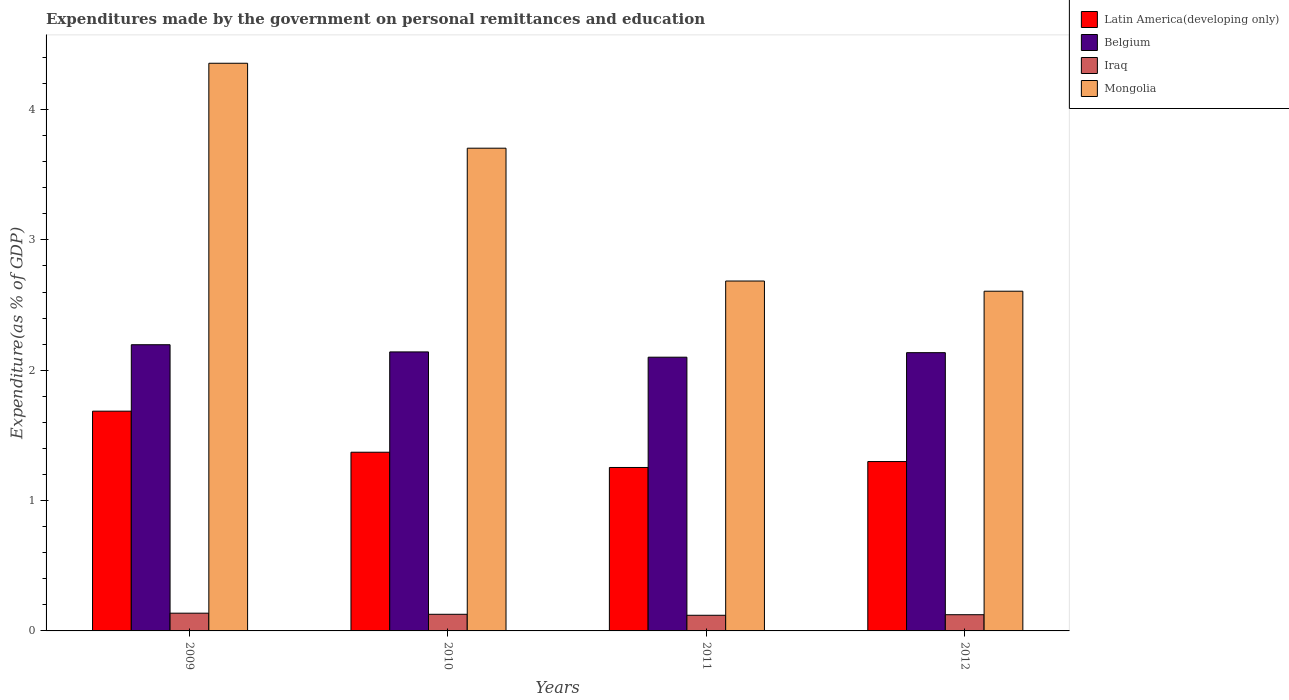How many different coloured bars are there?
Your response must be concise. 4. How many groups of bars are there?
Provide a short and direct response. 4. Are the number of bars per tick equal to the number of legend labels?
Your answer should be very brief. Yes. Are the number of bars on each tick of the X-axis equal?
Offer a very short reply. Yes. How many bars are there on the 4th tick from the right?
Offer a terse response. 4. What is the label of the 1st group of bars from the left?
Provide a succinct answer. 2009. In how many cases, is the number of bars for a given year not equal to the number of legend labels?
Your answer should be compact. 0. What is the expenditures made by the government on personal remittances and education in Belgium in 2009?
Your answer should be compact. 2.2. Across all years, what is the maximum expenditures made by the government on personal remittances and education in Mongolia?
Offer a very short reply. 4.35. Across all years, what is the minimum expenditures made by the government on personal remittances and education in Mongolia?
Make the answer very short. 2.61. What is the total expenditures made by the government on personal remittances and education in Iraq in the graph?
Make the answer very short. 0.51. What is the difference between the expenditures made by the government on personal remittances and education in Belgium in 2009 and that in 2011?
Your answer should be very brief. 0.1. What is the difference between the expenditures made by the government on personal remittances and education in Iraq in 2011 and the expenditures made by the government on personal remittances and education in Latin America(developing only) in 2009?
Your answer should be very brief. -1.57. What is the average expenditures made by the government on personal remittances and education in Mongolia per year?
Keep it short and to the point. 3.34. In the year 2011, what is the difference between the expenditures made by the government on personal remittances and education in Latin America(developing only) and expenditures made by the government on personal remittances and education in Iraq?
Your answer should be compact. 1.13. What is the ratio of the expenditures made by the government on personal remittances and education in Latin America(developing only) in 2009 to that in 2010?
Provide a short and direct response. 1.23. Is the expenditures made by the government on personal remittances and education in Latin America(developing only) in 2010 less than that in 2011?
Provide a short and direct response. No. What is the difference between the highest and the second highest expenditures made by the government on personal remittances and education in Mongolia?
Offer a very short reply. 0.65. What is the difference between the highest and the lowest expenditures made by the government on personal remittances and education in Belgium?
Provide a succinct answer. 0.1. In how many years, is the expenditures made by the government on personal remittances and education in Iraq greater than the average expenditures made by the government on personal remittances and education in Iraq taken over all years?
Your response must be concise. 2. What does the 3rd bar from the left in 2009 represents?
Ensure brevity in your answer.  Iraq. What does the 2nd bar from the right in 2009 represents?
Give a very brief answer. Iraq. How many bars are there?
Provide a short and direct response. 16. What is the difference between two consecutive major ticks on the Y-axis?
Your answer should be very brief. 1. How many legend labels are there?
Ensure brevity in your answer.  4. How are the legend labels stacked?
Keep it short and to the point. Vertical. What is the title of the graph?
Make the answer very short. Expenditures made by the government on personal remittances and education. Does "Denmark" appear as one of the legend labels in the graph?
Your answer should be compact. No. What is the label or title of the Y-axis?
Ensure brevity in your answer.  Expenditure(as % of GDP). What is the Expenditure(as % of GDP) of Latin America(developing only) in 2009?
Your answer should be compact. 1.69. What is the Expenditure(as % of GDP) in Belgium in 2009?
Your response must be concise. 2.2. What is the Expenditure(as % of GDP) of Iraq in 2009?
Offer a very short reply. 0.14. What is the Expenditure(as % of GDP) of Mongolia in 2009?
Offer a very short reply. 4.35. What is the Expenditure(as % of GDP) in Latin America(developing only) in 2010?
Keep it short and to the point. 1.37. What is the Expenditure(as % of GDP) in Belgium in 2010?
Offer a very short reply. 2.14. What is the Expenditure(as % of GDP) of Iraq in 2010?
Offer a terse response. 0.13. What is the Expenditure(as % of GDP) of Mongolia in 2010?
Offer a very short reply. 3.7. What is the Expenditure(as % of GDP) of Latin America(developing only) in 2011?
Provide a short and direct response. 1.25. What is the Expenditure(as % of GDP) in Belgium in 2011?
Keep it short and to the point. 2.1. What is the Expenditure(as % of GDP) in Iraq in 2011?
Ensure brevity in your answer.  0.12. What is the Expenditure(as % of GDP) in Mongolia in 2011?
Provide a short and direct response. 2.68. What is the Expenditure(as % of GDP) in Latin America(developing only) in 2012?
Keep it short and to the point. 1.3. What is the Expenditure(as % of GDP) of Belgium in 2012?
Offer a terse response. 2.13. What is the Expenditure(as % of GDP) in Iraq in 2012?
Ensure brevity in your answer.  0.12. What is the Expenditure(as % of GDP) of Mongolia in 2012?
Offer a terse response. 2.61. Across all years, what is the maximum Expenditure(as % of GDP) in Latin America(developing only)?
Offer a very short reply. 1.69. Across all years, what is the maximum Expenditure(as % of GDP) of Belgium?
Offer a terse response. 2.2. Across all years, what is the maximum Expenditure(as % of GDP) of Iraq?
Your response must be concise. 0.14. Across all years, what is the maximum Expenditure(as % of GDP) of Mongolia?
Offer a terse response. 4.35. Across all years, what is the minimum Expenditure(as % of GDP) in Latin America(developing only)?
Provide a short and direct response. 1.25. Across all years, what is the minimum Expenditure(as % of GDP) in Belgium?
Provide a short and direct response. 2.1. Across all years, what is the minimum Expenditure(as % of GDP) of Iraq?
Give a very brief answer. 0.12. Across all years, what is the minimum Expenditure(as % of GDP) of Mongolia?
Make the answer very short. 2.61. What is the total Expenditure(as % of GDP) in Latin America(developing only) in the graph?
Give a very brief answer. 5.61. What is the total Expenditure(as % of GDP) of Belgium in the graph?
Give a very brief answer. 8.57. What is the total Expenditure(as % of GDP) of Iraq in the graph?
Provide a succinct answer. 0.51. What is the total Expenditure(as % of GDP) of Mongolia in the graph?
Keep it short and to the point. 13.35. What is the difference between the Expenditure(as % of GDP) in Latin America(developing only) in 2009 and that in 2010?
Provide a short and direct response. 0.32. What is the difference between the Expenditure(as % of GDP) in Belgium in 2009 and that in 2010?
Ensure brevity in your answer.  0.06. What is the difference between the Expenditure(as % of GDP) in Iraq in 2009 and that in 2010?
Offer a terse response. 0.01. What is the difference between the Expenditure(as % of GDP) of Mongolia in 2009 and that in 2010?
Make the answer very short. 0.65. What is the difference between the Expenditure(as % of GDP) of Latin America(developing only) in 2009 and that in 2011?
Offer a very short reply. 0.43. What is the difference between the Expenditure(as % of GDP) in Belgium in 2009 and that in 2011?
Your answer should be compact. 0.1. What is the difference between the Expenditure(as % of GDP) of Iraq in 2009 and that in 2011?
Offer a very short reply. 0.02. What is the difference between the Expenditure(as % of GDP) in Mongolia in 2009 and that in 2011?
Offer a terse response. 1.67. What is the difference between the Expenditure(as % of GDP) of Latin America(developing only) in 2009 and that in 2012?
Offer a very short reply. 0.39. What is the difference between the Expenditure(as % of GDP) in Belgium in 2009 and that in 2012?
Offer a very short reply. 0.06. What is the difference between the Expenditure(as % of GDP) of Iraq in 2009 and that in 2012?
Offer a terse response. 0.01. What is the difference between the Expenditure(as % of GDP) of Mongolia in 2009 and that in 2012?
Keep it short and to the point. 1.75. What is the difference between the Expenditure(as % of GDP) of Latin America(developing only) in 2010 and that in 2011?
Offer a very short reply. 0.12. What is the difference between the Expenditure(as % of GDP) of Belgium in 2010 and that in 2011?
Offer a very short reply. 0.04. What is the difference between the Expenditure(as % of GDP) of Iraq in 2010 and that in 2011?
Ensure brevity in your answer.  0.01. What is the difference between the Expenditure(as % of GDP) in Latin America(developing only) in 2010 and that in 2012?
Your answer should be very brief. 0.07. What is the difference between the Expenditure(as % of GDP) in Belgium in 2010 and that in 2012?
Make the answer very short. 0.01. What is the difference between the Expenditure(as % of GDP) in Iraq in 2010 and that in 2012?
Give a very brief answer. 0. What is the difference between the Expenditure(as % of GDP) of Mongolia in 2010 and that in 2012?
Make the answer very short. 1.1. What is the difference between the Expenditure(as % of GDP) of Latin America(developing only) in 2011 and that in 2012?
Make the answer very short. -0.05. What is the difference between the Expenditure(as % of GDP) in Belgium in 2011 and that in 2012?
Keep it short and to the point. -0.03. What is the difference between the Expenditure(as % of GDP) of Iraq in 2011 and that in 2012?
Offer a very short reply. -0. What is the difference between the Expenditure(as % of GDP) in Mongolia in 2011 and that in 2012?
Offer a terse response. 0.08. What is the difference between the Expenditure(as % of GDP) of Latin America(developing only) in 2009 and the Expenditure(as % of GDP) of Belgium in 2010?
Provide a succinct answer. -0.45. What is the difference between the Expenditure(as % of GDP) of Latin America(developing only) in 2009 and the Expenditure(as % of GDP) of Iraq in 2010?
Keep it short and to the point. 1.56. What is the difference between the Expenditure(as % of GDP) of Latin America(developing only) in 2009 and the Expenditure(as % of GDP) of Mongolia in 2010?
Your response must be concise. -2.02. What is the difference between the Expenditure(as % of GDP) of Belgium in 2009 and the Expenditure(as % of GDP) of Iraq in 2010?
Make the answer very short. 2.07. What is the difference between the Expenditure(as % of GDP) of Belgium in 2009 and the Expenditure(as % of GDP) of Mongolia in 2010?
Make the answer very short. -1.51. What is the difference between the Expenditure(as % of GDP) of Iraq in 2009 and the Expenditure(as % of GDP) of Mongolia in 2010?
Make the answer very short. -3.57. What is the difference between the Expenditure(as % of GDP) of Latin America(developing only) in 2009 and the Expenditure(as % of GDP) of Belgium in 2011?
Provide a short and direct response. -0.41. What is the difference between the Expenditure(as % of GDP) in Latin America(developing only) in 2009 and the Expenditure(as % of GDP) in Iraq in 2011?
Keep it short and to the point. 1.57. What is the difference between the Expenditure(as % of GDP) in Latin America(developing only) in 2009 and the Expenditure(as % of GDP) in Mongolia in 2011?
Offer a very short reply. -1. What is the difference between the Expenditure(as % of GDP) in Belgium in 2009 and the Expenditure(as % of GDP) in Iraq in 2011?
Keep it short and to the point. 2.08. What is the difference between the Expenditure(as % of GDP) of Belgium in 2009 and the Expenditure(as % of GDP) of Mongolia in 2011?
Provide a short and direct response. -0.49. What is the difference between the Expenditure(as % of GDP) of Iraq in 2009 and the Expenditure(as % of GDP) of Mongolia in 2011?
Make the answer very short. -2.55. What is the difference between the Expenditure(as % of GDP) of Latin America(developing only) in 2009 and the Expenditure(as % of GDP) of Belgium in 2012?
Make the answer very short. -0.45. What is the difference between the Expenditure(as % of GDP) in Latin America(developing only) in 2009 and the Expenditure(as % of GDP) in Iraq in 2012?
Provide a short and direct response. 1.56. What is the difference between the Expenditure(as % of GDP) in Latin America(developing only) in 2009 and the Expenditure(as % of GDP) in Mongolia in 2012?
Provide a short and direct response. -0.92. What is the difference between the Expenditure(as % of GDP) of Belgium in 2009 and the Expenditure(as % of GDP) of Iraq in 2012?
Make the answer very short. 2.07. What is the difference between the Expenditure(as % of GDP) of Belgium in 2009 and the Expenditure(as % of GDP) of Mongolia in 2012?
Provide a short and direct response. -0.41. What is the difference between the Expenditure(as % of GDP) in Iraq in 2009 and the Expenditure(as % of GDP) in Mongolia in 2012?
Provide a short and direct response. -2.47. What is the difference between the Expenditure(as % of GDP) of Latin America(developing only) in 2010 and the Expenditure(as % of GDP) of Belgium in 2011?
Ensure brevity in your answer.  -0.73. What is the difference between the Expenditure(as % of GDP) of Latin America(developing only) in 2010 and the Expenditure(as % of GDP) of Iraq in 2011?
Your answer should be compact. 1.25. What is the difference between the Expenditure(as % of GDP) in Latin America(developing only) in 2010 and the Expenditure(as % of GDP) in Mongolia in 2011?
Keep it short and to the point. -1.31. What is the difference between the Expenditure(as % of GDP) in Belgium in 2010 and the Expenditure(as % of GDP) in Iraq in 2011?
Give a very brief answer. 2.02. What is the difference between the Expenditure(as % of GDP) of Belgium in 2010 and the Expenditure(as % of GDP) of Mongolia in 2011?
Offer a very short reply. -0.54. What is the difference between the Expenditure(as % of GDP) in Iraq in 2010 and the Expenditure(as % of GDP) in Mongolia in 2011?
Provide a succinct answer. -2.56. What is the difference between the Expenditure(as % of GDP) in Latin America(developing only) in 2010 and the Expenditure(as % of GDP) in Belgium in 2012?
Provide a short and direct response. -0.76. What is the difference between the Expenditure(as % of GDP) of Latin America(developing only) in 2010 and the Expenditure(as % of GDP) of Iraq in 2012?
Make the answer very short. 1.25. What is the difference between the Expenditure(as % of GDP) of Latin America(developing only) in 2010 and the Expenditure(as % of GDP) of Mongolia in 2012?
Ensure brevity in your answer.  -1.24. What is the difference between the Expenditure(as % of GDP) of Belgium in 2010 and the Expenditure(as % of GDP) of Iraq in 2012?
Provide a succinct answer. 2.02. What is the difference between the Expenditure(as % of GDP) in Belgium in 2010 and the Expenditure(as % of GDP) in Mongolia in 2012?
Your answer should be very brief. -0.47. What is the difference between the Expenditure(as % of GDP) in Iraq in 2010 and the Expenditure(as % of GDP) in Mongolia in 2012?
Make the answer very short. -2.48. What is the difference between the Expenditure(as % of GDP) in Latin America(developing only) in 2011 and the Expenditure(as % of GDP) in Belgium in 2012?
Offer a terse response. -0.88. What is the difference between the Expenditure(as % of GDP) of Latin America(developing only) in 2011 and the Expenditure(as % of GDP) of Iraq in 2012?
Keep it short and to the point. 1.13. What is the difference between the Expenditure(as % of GDP) of Latin America(developing only) in 2011 and the Expenditure(as % of GDP) of Mongolia in 2012?
Give a very brief answer. -1.35. What is the difference between the Expenditure(as % of GDP) of Belgium in 2011 and the Expenditure(as % of GDP) of Iraq in 2012?
Keep it short and to the point. 1.98. What is the difference between the Expenditure(as % of GDP) in Belgium in 2011 and the Expenditure(as % of GDP) in Mongolia in 2012?
Provide a succinct answer. -0.51. What is the difference between the Expenditure(as % of GDP) in Iraq in 2011 and the Expenditure(as % of GDP) in Mongolia in 2012?
Offer a very short reply. -2.49. What is the average Expenditure(as % of GDP) of Latin America(developing only) per year?
Provide a succinct answer. 1.4. What is the average Expenditure(as % of GDP) in Belgium per year?
Ensure brevity in your answer.  2.14. What is the average Expenditure(as % of GDP) of Iraq per year?
Your answer should be very brief. 0.13. What is the average Expenditure(as % of GDP) in Mongolia per year?
Your answer should be very brief. 3.34. In the year 2009, what is the difference between the Expenditure(as % of GDP) of Latin America(developing only) and Expenditure(as % of GDP) of Belgium?
Provide a short and direct response. -0.51. In the year 2009, what is the difference between the Expenditure(as % of GDP) of Latin America(developing only) and Expenditure(as % of GDP) of Iraq?
Offer a terse response. 1.55. In the year 2009, what is the difference between the Expenditure(as % of GDP) in Latin America(developing only) and Expenditure(as % of GDP) in Mongolia?
Your response must be concise. -2.67. In the year 2009, what is the difference between the Expenditure(as % of GDP) in Belgium and Expenditure(as % of GDP) in Iraq?
Your answer should be very brief. 2.06. In the year 2009, what is the difference between the Expenditure(as % of GDP) of Belgium and Expenditure(as % of GDP) of Mongolia?
Your answer should be compact. -2.16. In the year 2009, what is the difference between the Expenditure(as % of GDP) in Iraq and Expenditure(as % of GDP) in Mongolia?
Your answer should be compact. -4.22. In the year 2010, what is the difference between the Expenditure(as % of GDP) of Latin America(developing only) and Expenditure(as % of GDP) of Belgium?
Your response must be concise. -0.77. In the year 2010, what is the difference between the Expenditure(as % of GDP) of Latin America(developing only) and Expenditure(as % of GDP) of Iraq?
Make the answer very short. 1.24. In the year 2010, what is the difference between the Expenditure(as % of GDP) of Latin America(developing only) and Expenditure(as % of GDP) of Mongolia?
Offer a terse response. -2.33. In the year 2010, what is the difference between the Expenditure(as % of GDP) in Belgium and Expenditure(as % of GDP) in Iraq?
Make the answer very short. 2.01. In the year 2010, what is the difference between the Expenditure(as % of GDP) in Belgium and Expenditure(as % of GDP) in Mongolia?
Provide a short and direct response. -1.56. In the year 2010, what is the difference between the Expenditure(as % of GDP) in Iraq and Expenditure(as % of GDP) in Mongolia?
Your answer should be compact. -3.58. In the year 2011, what is the difference between the Expenditure(as % of GDP) in Latin America(developing only) and Expenditure(as % of GDP) in Belgium?
Your response must be concise. -0.85. In the year 2011, what is the difference between the Expenditure(as % of GDP) of Latin America(developing only) and Expenditure(as % of GDP) of Iraq?
Your answer should be very brief. 1.13. In the year 2011, what is the difference between the Expenditure(as % of GDP) in Latin America(developing only) and Expenditure(as % of GDP) in Mongolia?
Offer a very short reply. -1.43. In the year 2011, what is the difference between the Expenditure(as % of GDP) in Belgium and Expenditure(as % of GDP) in Iraq?
Your answer should be compact. 1.98. In the year 2011, what is the difference between the Expenditure(as % of GDP) of Belgium and Expenditure(as % of GDP) of Mongolia?
Make the answer very short. -0.58. In the year 2011, what is the difference between the Expenditure(as % of GDP) of Iraq and Expenditure(as % of GDP) of Mongolia?
Provide a succinct answer. -2.56. In the year 2012, what is the difference between the Expenditure(as % of GDP) in Latin America(developing only) and Expenditure(as % of GDP) in Belgium?
Your answer should be very brief. -0.84. In the year 2012, what is the difference between the Expenditure(as % of GDP) of Latin America(developing only) and Expenditure(as % of GDP) of Iraq?
Make the answer very short. 1.18. In the year 2012, what is the difference between the Expenditure(as % of GDP) of Latin America(developing only) and Expenditure(as % of GDP) of Mongolia?
Ensure brevity in your answer.  -1.31. In the year 2012, what is the difference between the Expenditure(as % of GDP) of Belgium and Expenditure(as % of GDP) of Iraq?
Offer a terse response. 2.01. In the year 2012, what is the difference between the Expenditure(as % of GDP) in Belgium and Expenditure(as % of GDP) in Mongolia?
Give a very brief answer. -0.47. In the year 2012, what is the difference between the Expenditure(as % of GDP) of Iraq and Expenditure(as % of GDP) of Mongolia?
Offer a very short reply. -2.48. What is the ratio of the Expenditure(as % of GDP) of Latin America(developing only) in 2009 to that in 2010?
Provide a short and direct response. 1.23. What is the ratio of the Expenditure(as % of GDP) in Belgium in 2009 to that in 2010?
Your answer should be compact. 1.03. What is the ratio of the Expenditure(as % of GDP) of Iraq in 2009 to that in 2010?
Keep it short and to the point. 1.07. What is the ratio of the Expenditure(as % of GDP) in Mongolia in 2009 to that in 2010?
Offer a very short reply. 1.18. What is the ratio of the Expenditure(as % of GDP) of Latin America(developing only) in 2009 to that in 2011?
Your response must be concise. 1.34. What is the ratio of the Expenditure(as % of GDP) of Belgium in 2009 to that in 2011?
Your response must be concise. 1.05. What is the ratio of the Expenditure(as % of GDP) in Iraq in 2009 to that in 2011?
Offer a very short reply. 1.13. What is the ratio of the Expenditure(as % of GDP) of Mongolia in 2009 to that in 2011?
Provide a short and direct response. 1.62. What is the ratio of the Expenditure(as % of GDP) in Latin America(developing only) in 2009 to that in 2012?
Offer a terse response. 1.3. What is the ratio of the Expenditure(as % of GDP) of Belgium in 2009 to that in 2012?
Provide a succinct answer. 1.03. What is the ratio of the Expenditure(as % of GDP) in Iraq in 2009 to that in 2012?
Give a very brief answer. 1.09. What is the ratio of the Expenditure(as % of GDP) in Mongolia in 2009 to that in 2012?
Your response must be concise. 1.67. What is the ratio of the Expenditure(as % of GDP) in Latin America(developing only) in 2010 to that in 2011?
Keep it short and to the point. 1.09. What is the ratio of the Expenditure(as % of GDP) in Belgium in 2010 to that in 2011?
Make the answer very short. 1.02. What is the ratio of the Expenditure(as % of GDP) in Iraq in 2010 to that in 2011?
Your response must be concise. 1.06. What is the ratio of the Expenditure(as % of GDP) in Mongolia in 2010 to that in 2011?
Your response must be concise. 1.38. What is the ratio of the Expenditure(as % of GDP) in Latin America(developing only) in 2010 to that in 2012?
Your answer should be very brief. 1.05. What is the ratio of the Expenditure(as % of GDP) in Iraq in 2010 to that in 2012?
Ensure brevity in your answer.  1.03. What is the ratio of the Expenditure(as % of GDP) in Mongolia in 2010 to that in 2012?
Offer a terse response. 1.42. What is the ratio of the Expenditure(as % of GDP) in Latin America(developing only) in 2011 to that in 2012?
Your answer should be compact. 0.97. What is the ratio of the Expenditure(as % of GDP) of Belgium in 2011 to that in 2012?
Your answer should be compact. 0.98. What is the ratio of the Expenditure(as % of GDP) in Iraq in 2011 to that in 2012?
Provide a succinct answer. 0.97. What is the ratio of the Expenditure(as % of GDP) of Mongolia in 2011 to that in 2012?
Offer a terse response. 1.03. What is the difference between the highest and the second highest Expenditure(as % of GDP) in Latin America(developing only)?
Provide a succinct answer. 0.32. What is the difference between the highest and the second highest Expenditure(as % of GDP) in Belgium?
Give a very brief answer. 0.06. What is the difference between the highest and the second highest Expenditure(as % of GDP) of Iraq?
Provide a short and direct response. 0.01. What is the difference between the highest and the second highest Expenditure(as % of GDP) of Mongolia?
Give a very brief answer. 0.65. What is the difference between the highest and the lowest Expenditure(as % of GDP) in Latin America(developing only)?
Your response must be concise. 0.43. What is the difference between the highest and the lowest Expenditure(as % of GDP) of Belgium?
Provide a succinct answer. 0.1. What is the difference between the highest and the lowest Expenditure(as % of GDP) of Iraq?
Provide a succinct answer. 0.02. What is the difference between the highest and the lowest Expenditure(as % of GDP) in Mongolia?
Make the answer very short. 1.75. 